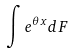<formula> <loc_0><loc_0><loc_500><loc_500>\int e ^ { \theta x } d F</formula> 